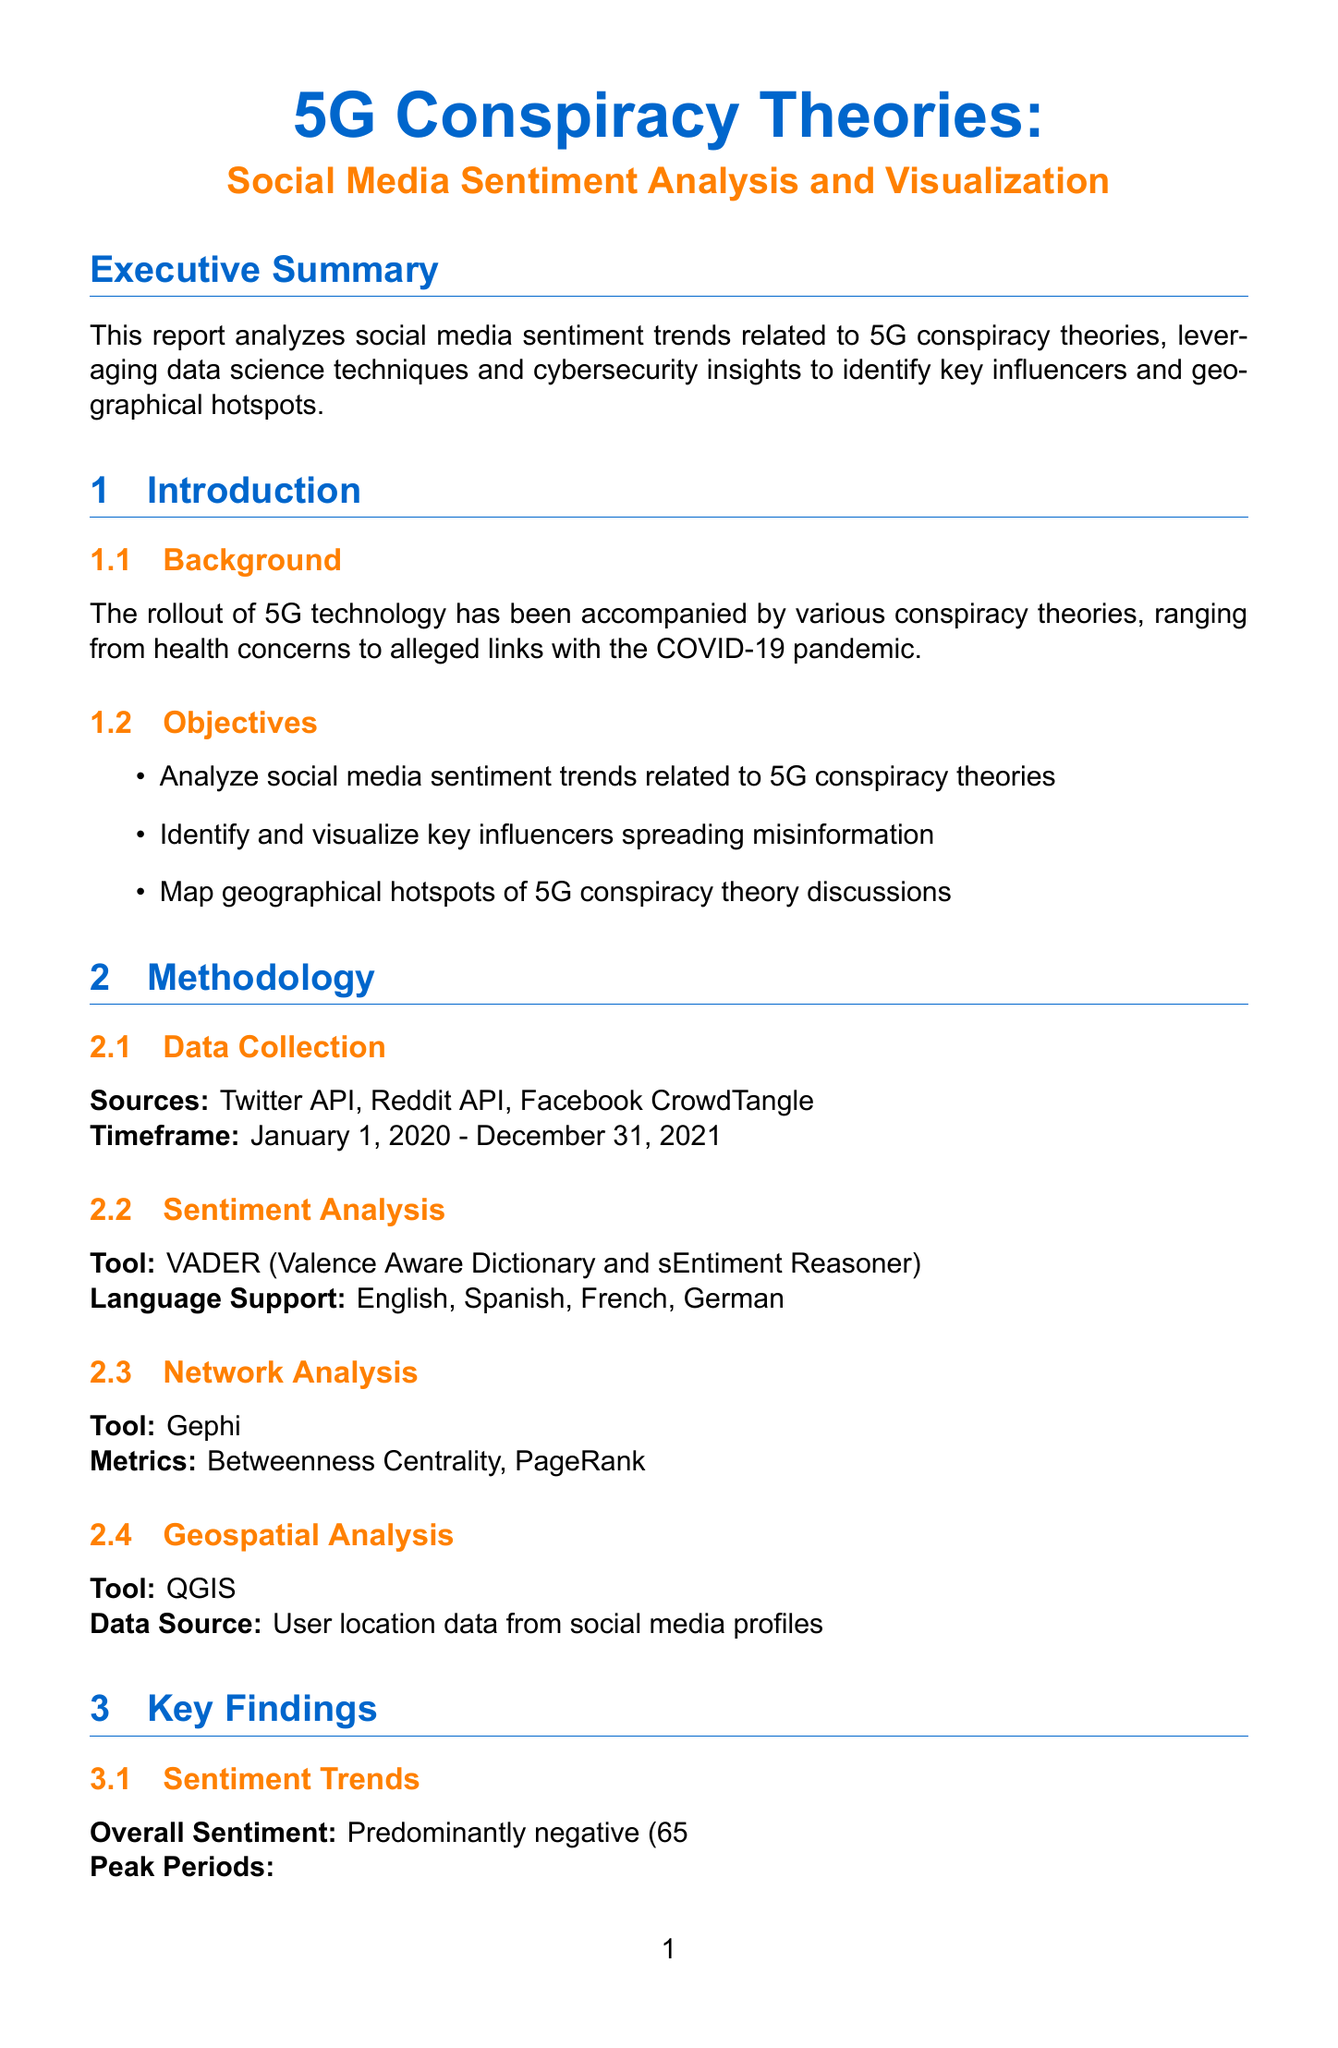What was the overall sentiment of posts related to 5G conspiracy theories? The overall sentiment indicates the general public's opinion towards 5G conspiracy theories, which is stated as predominantly negative.
Answer: Predominantly negative (65% of posts) When did the surge of COVID-19 and 5G conspiracy theory links occur? This peak period links a significant event with an increase in related conspiracy discussions, specifically in April 2020.
Answer: April 2020 Who is the top influencer on Facebook? The document lists key influencers along with their social media platforms, noting 'Natural News' as the top influencer on Facebook.
Answer: Natural News What percentage of total posts comes from the United States? The document details geographical hotspots, stating the proportion of posts related to 5G conspiracy theories originating from the United States.
Answer: 35% Which tool was used for sentiment analysis? The methodology section specifies the tool utilized for conducting sentiment analysis on the data collected.
Answer: VADER (Valence Aware Dictionary and sEntiment Reasoner) What social media platform had the highest engagement rate among top influencers? The document mentions engagement rates and identifies 'InfoWars' on YouTube as having the highest engagement figure.
Answer: 5.1% What should be implemented in educational curricula, according to policy recommendations? The recommendations suggest practical steps to improve digital literacy, particularly targeting schools and education systems.
Answer: Digital literacy programs Which tool is mentioned for network analysis? The methodology includes details about analytical tools, specifically naming one used for network analysis.
Answer: Gephi What country has the highest percentage of conspiracy theory posts? The geographical hotspots section indicates which country has the most users discussing conspiracy theories regarding 5G.
Answer: United States 